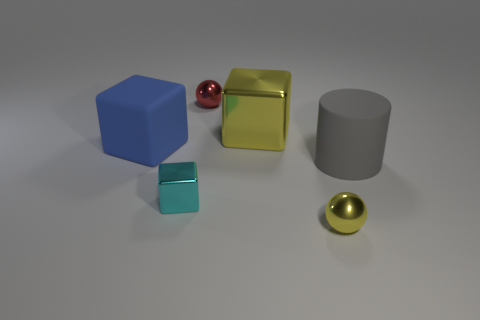Are there any other things that have the same shape as the large gray rubber object?
Your answer should be very brief. No. What number of other things are there of the same material as the small cyan block
Your answer should be compact. 3. There is a tiny object to the left of the small red metallic thing; what shape is it?
Make the answer very short. Cube. There is a block on the left side of the shiny block in front of the large cylinder; what is its material?
Your response must be concise. Rubber. Are there more yellow things that are in front of the tiny red shiny sphere than tiny cyan shiny objects?
Give a very brief answer. Yes. What number of other objects are there of the same color as the large metallic object?
Your answer should be compact. 1. The metallic object that is the same size as the blue block is what shape?
Keep it short and to the point. Cube. What number of things are in front of the object that is right of the tiny metallic sphere that is in front of the tiny cyan object?
Your answer should be very brief. 2. What number of metallic objects are spheres or small cyan blocks?
Provide a succinct answer. 3. There is a metallic object that is behind the blue rubber thing and to the right of the small red ball; what color is it?
Offer a terse response. Yellow. 